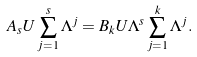Convert formula to latex. <formula><loc_0><loc_0><loc_500><loc_500>A _ { s } U \sum _ { j = 1 } ^ { s } \Lambda ^ { j } = B _ { k } U \Lambda ^ { s } \sum _ { j = 1 } ^ { k } \Lambda ^ { j } .</formula> 